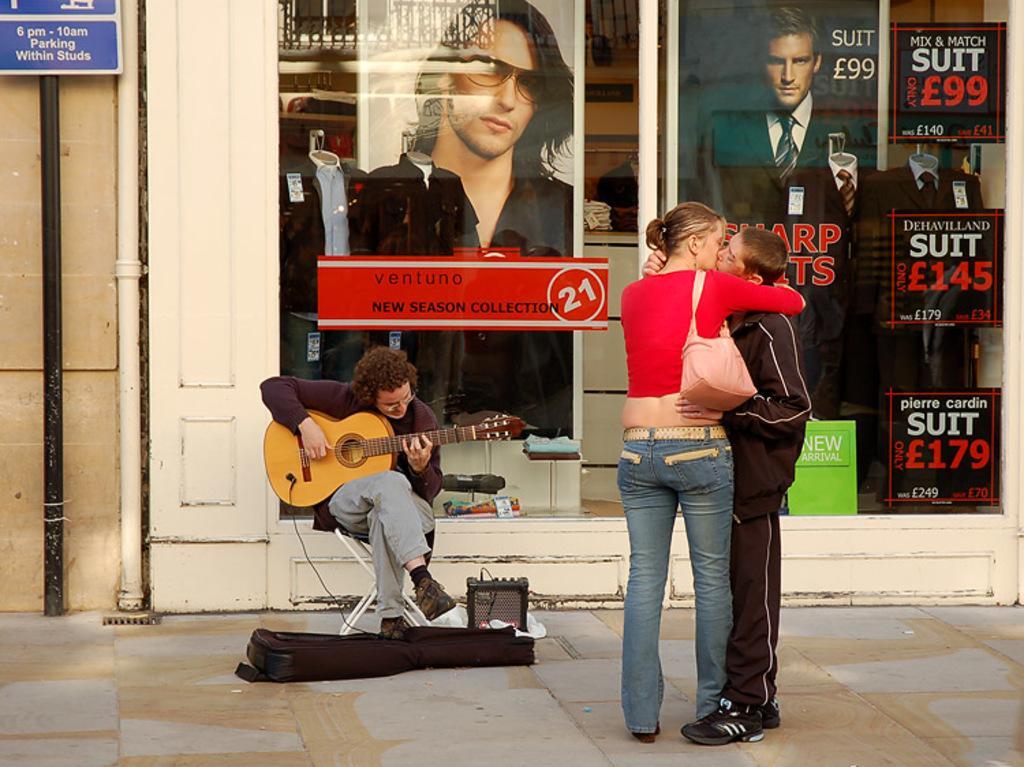In one or two sentences, can you explain what this image depicts? In this picture we can see three people and the one is sitting on the stool and playing the guitar and other two are kissing each other and behind them there is wall on which there are some postures. 